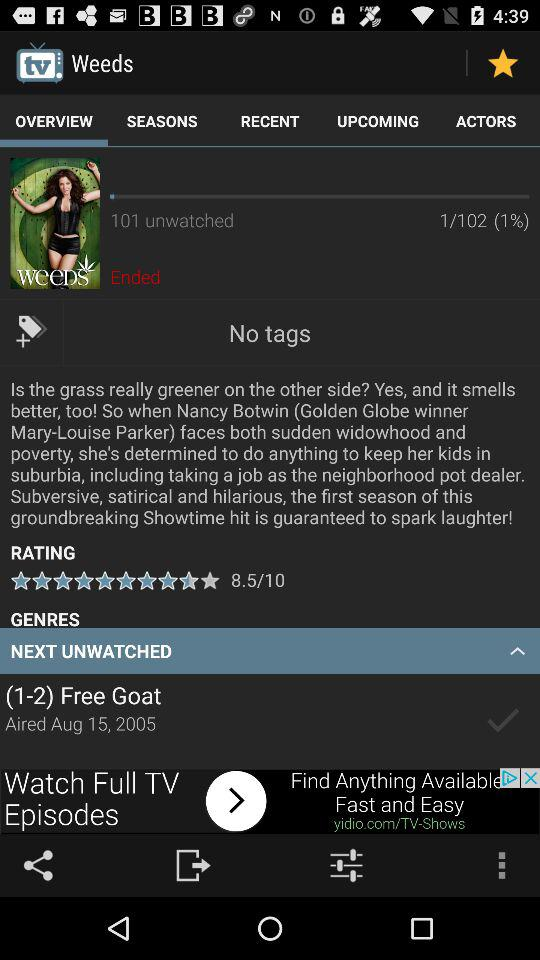What is the next unwatched episode of "Weeds"? The next unwatched episode is "(1-2) Free Goat". 